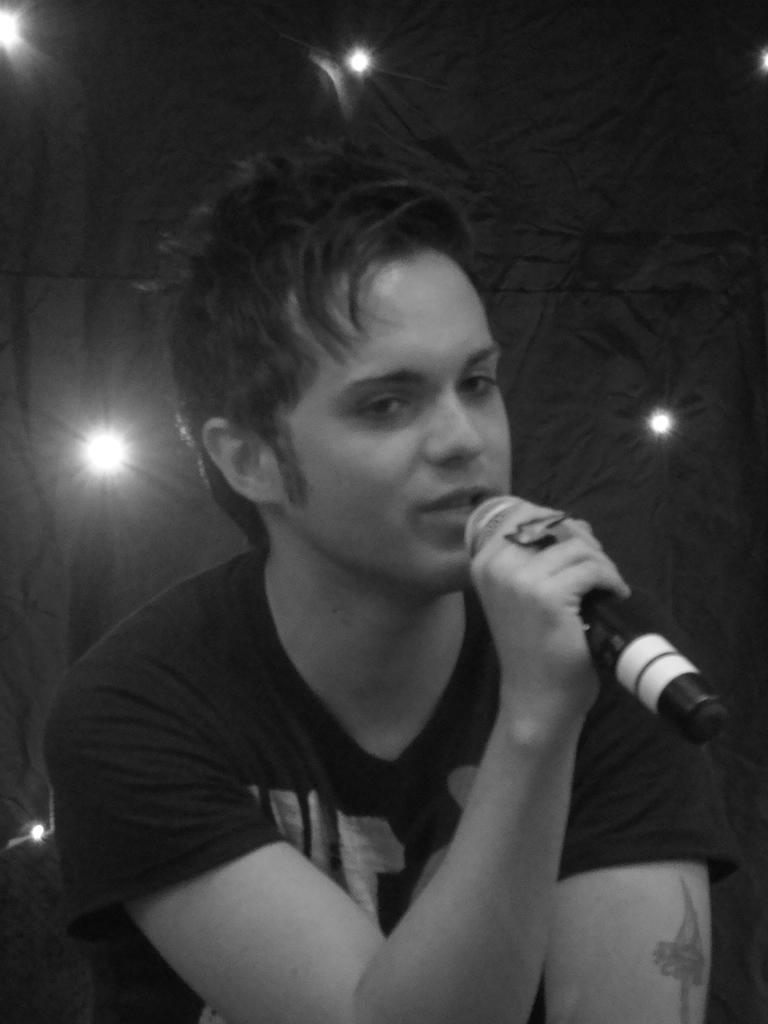What is the main subject of the image? There is a person in the image. What is the person holding in the image? The person is holding a microphone. What is the person doing in the image? The person is speaking, as evidenced by their visible mouth. What can be seen in the background of the image? There is a light in the background of the image. How does the person's foot feel in the image? There is no information about the person's foot in the image, so it cannot be determined how it feels. 